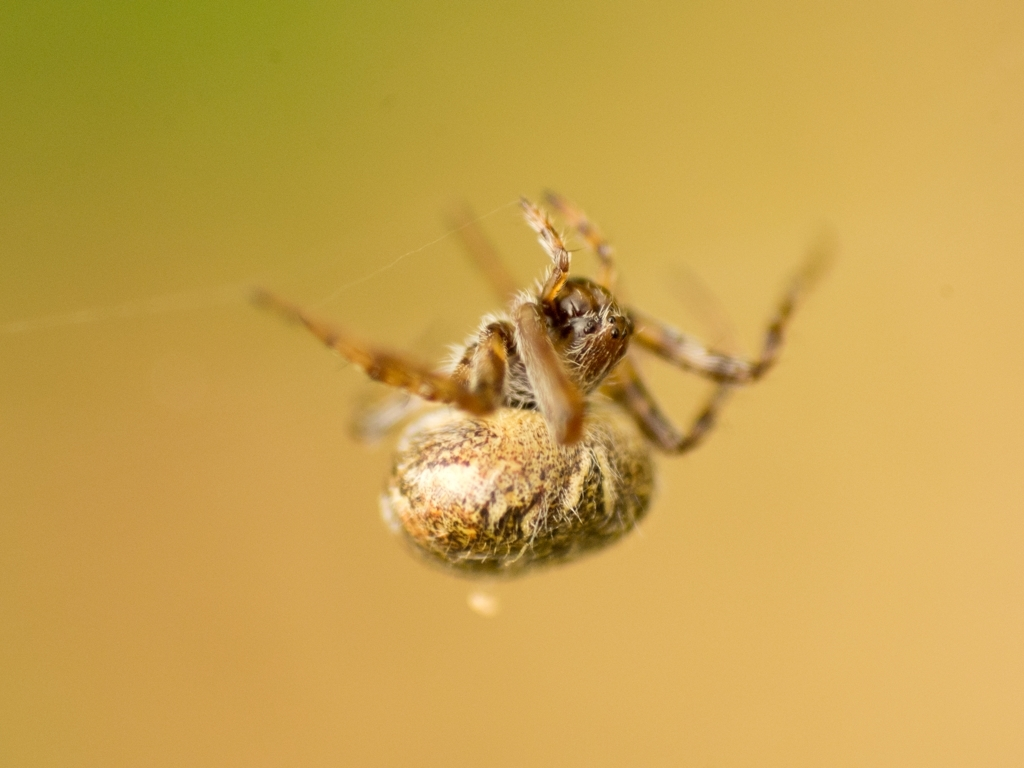Are the wings in focus? The wings of the spider seem slightly out of focus due to the shallow depth of field. The spider's body is the primary point of focus in the image, while the wings on the other insects captured in this scene are not present or clearly visible. 